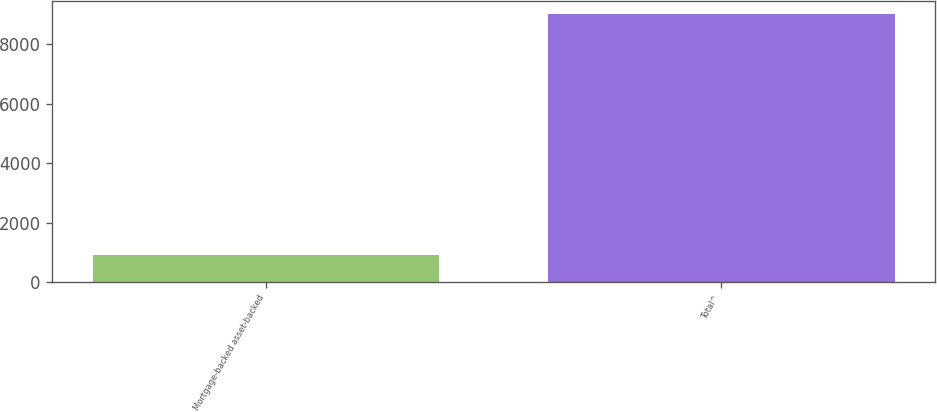Convert chart to OTSL. <chart><loc_0><loc_0><loc_500><loc_500><bar_chart><fcel>Mortgage-backed asset-backed<fcel>Total^<nl><fcel>920<fcel>9006<nl></chart> 